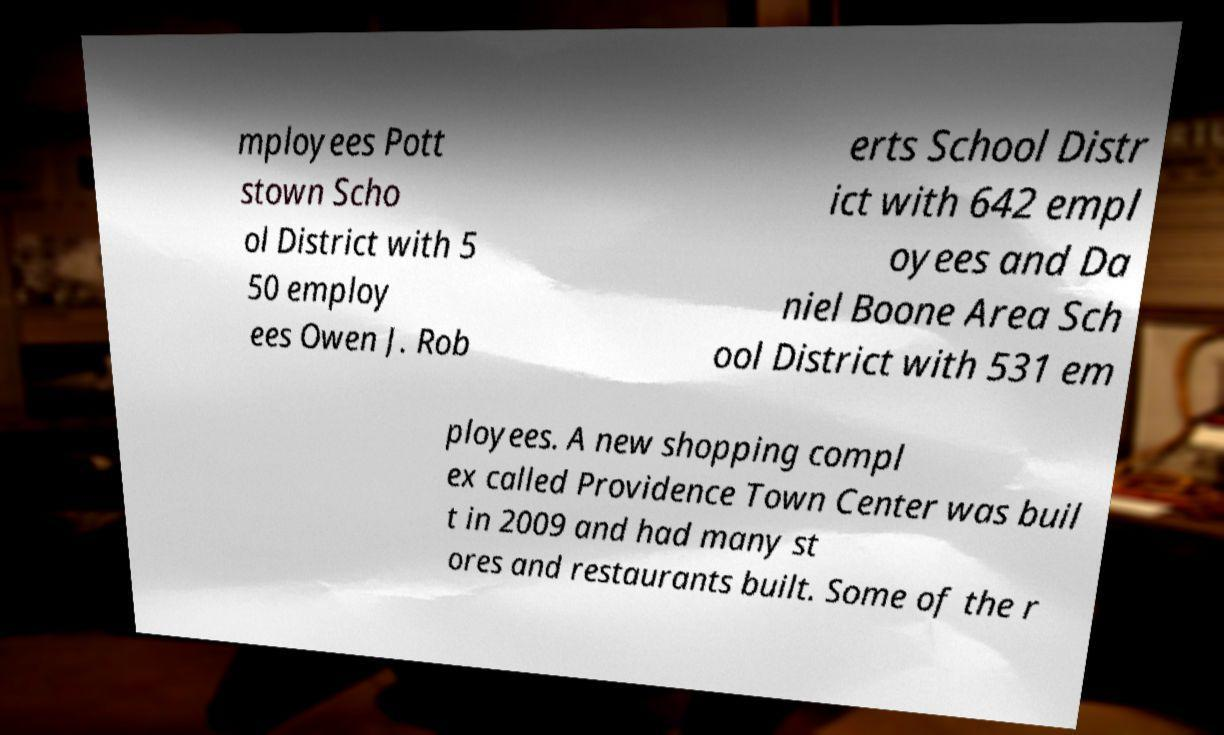For documentation purposes, I need the text within this image transcribed. Could you provide that? mployees Pott stown Scho ol District with 5 50 employ ees Owen J. Rob erts School Distr ict with 642 empl oyees and Da niel Boone Area Sch ool District with 531 em ployees. A new shopping compl ex called Providence Town Center was buil t in 2009 and had many st ores and restaurants built. Some of the r 